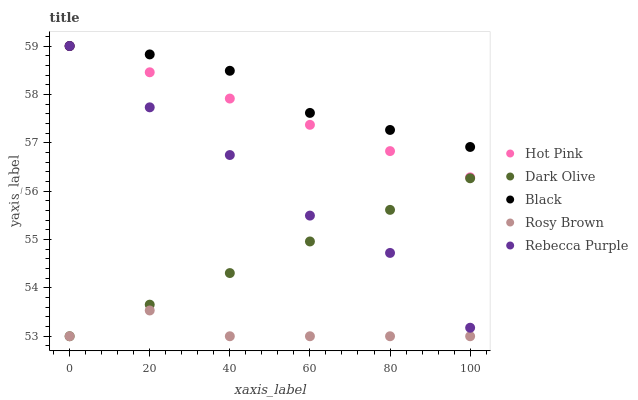Does Rosy Brown have the minimum area under the curve?
Answer yes or no. Yes. Does Black have the maximum area under the curve?
Answer yes or no. Yes. Does Hot Pink have the minimum area under the curve?
Answer yes or no. No. Does Hot Pink have the maximum area under the curve?
Answer yes or no. No. Is Hot Pink the smoothest?
Answer yes or no. Yes. Is Rebecca Purple the roughest?
Answer yes or no. Yes. Is Rosy Brown the smoothest?
Answer yes or no. No. Is Rosy Brown the roughest?
Answer yes or no. No. Does Dark Olive have the lowest value?
Answer yes or no. Yes. Does Hot Pink have the lowest value?
Answer yes or no. No. Does Rebecca Purple have the highest value?
Answer yes or no. Yes. Does Rosy Brown have the highest value?
Answer yes or no. No. Is Dark Olive less than Hot Pink?
Answer yes or no. Yes. Is Rebecca Purple greater than Rosy Brown?
Answer yes or no. Yes. Does Dark Olive intersect Rebecca Purple?
Answer yes or no. Yes. Is Dark Olive less than Rebecca Purple?
Answer yes or no. No. Is Dark Olive greater than Rebecca Purple?
Answer yes or no. No. Does Dark Olive intersect Hot Pink?
Answer yes or no. No. 